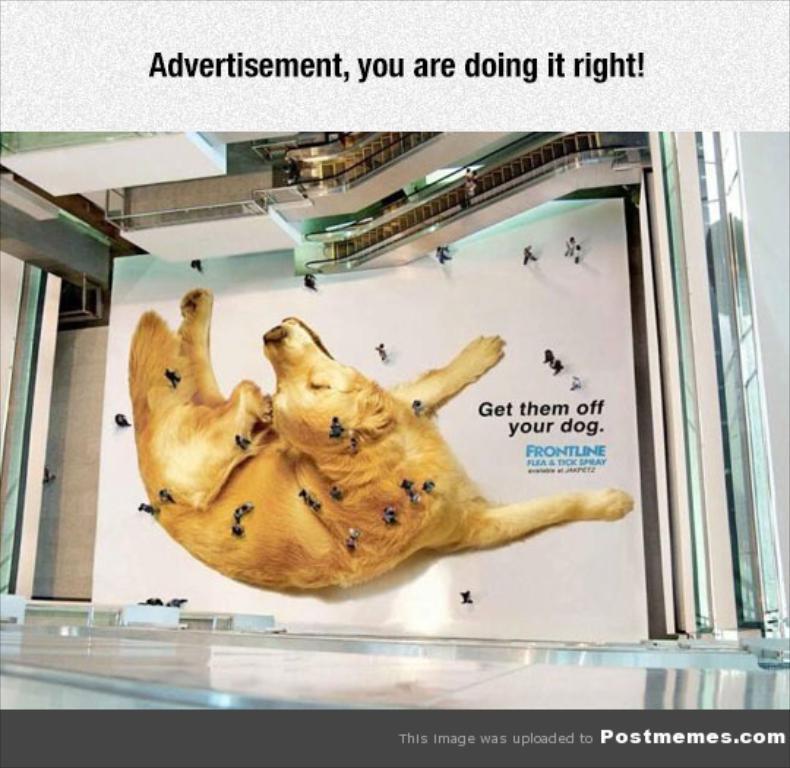In one or two sentences, can you explain what this image depicts? In this picture we can see a floor, on the floor we can see the picture of a dog, people and in the background we can see escalators, some objects and we can see some text on it. 